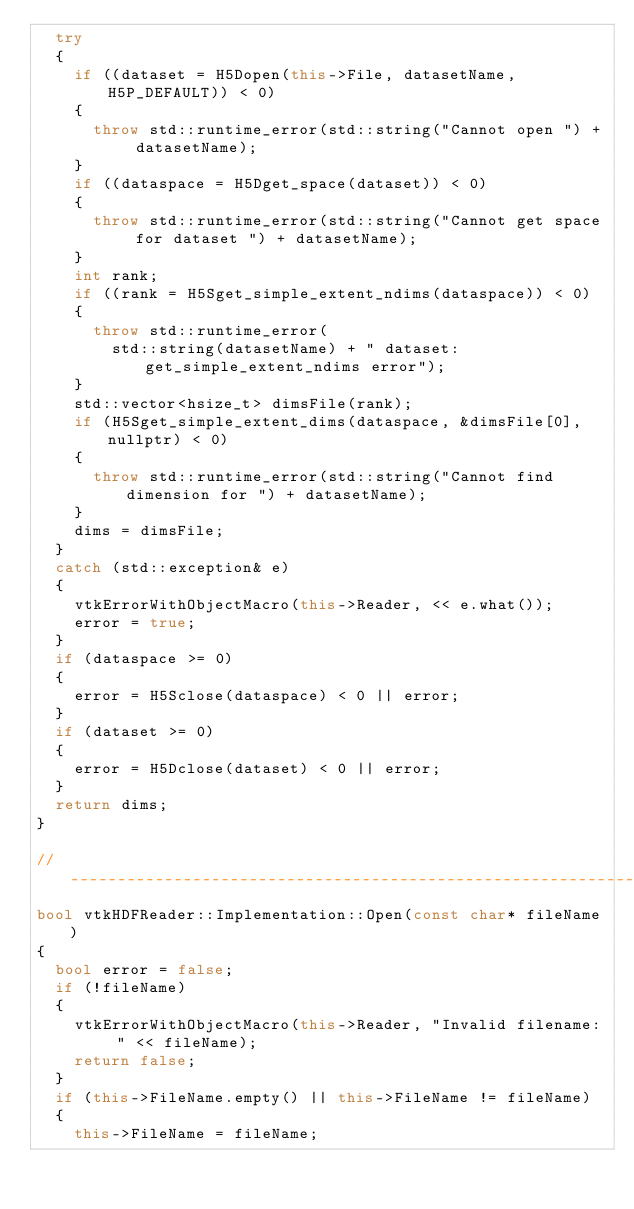<code> <loc_0><loc_0><loc_500><loc_500><_C++_>  try
  {
    if ((dataset = H5Dopen(this->File, datasetName, H5P_DEFAULT)) < 0)
    {
      throw std::runtime_error(std::string("Cannot open ") + datasetName);
    }
    if ((dataspace = H5Dget_space(dataset)) < 0)
    {
      throw std::runtime_error(std::string("Cannot get space for dataset ") + datasetName);
    }
    int rank;
    if ((rank = H5Sget_simple_extent_ndims(dataspace)) < 0)
    {
      throw std::runtime_error(
        std::string(datasetName) + " dataset: get_simple_extent_ndims error");
    }
    std::vector<hsize_t> dimsFile(rank);
    if (H5Sget_simple_extent_dims(dataspace, &dimsFile[0], nullptr) < 0)
    {
      throw std::runtime_error(std::string("Cannot find dimension for ") + datasetName);
    }
    dims = dimsFile;
  }
  catch (std::exception& e)
  {
    vtkErrorWithObjectMacro(this->Reader, << e.what());
    error = true;
  }
  if (dataspace >= 0)
  {
    error = H5Sclose(dataspace) < 0 || error;
  }
  if (dataset >= 0)
  {
    error = H5Dclose(dataset) < 0 || error;
  }
  return dims;
}

//------------------------------------------------------------------------------
bool vtkHDFReader::Implementation::Open(const char* fileName)
{
  bool error = false;
  if (!fileName)
  {
    vtkErrorWithObjectMacro(this->Reader, "Invalid filename: " << fileName);
    return false;
  }
  if (this->FileName.empty() || this->FileName != fileName)
  {
    this->FileName = fileName;</code> 